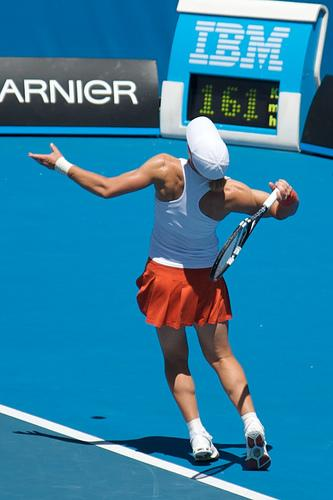What is the person doing? Please explain your reasoning. serving. The person is hitting the ball. 